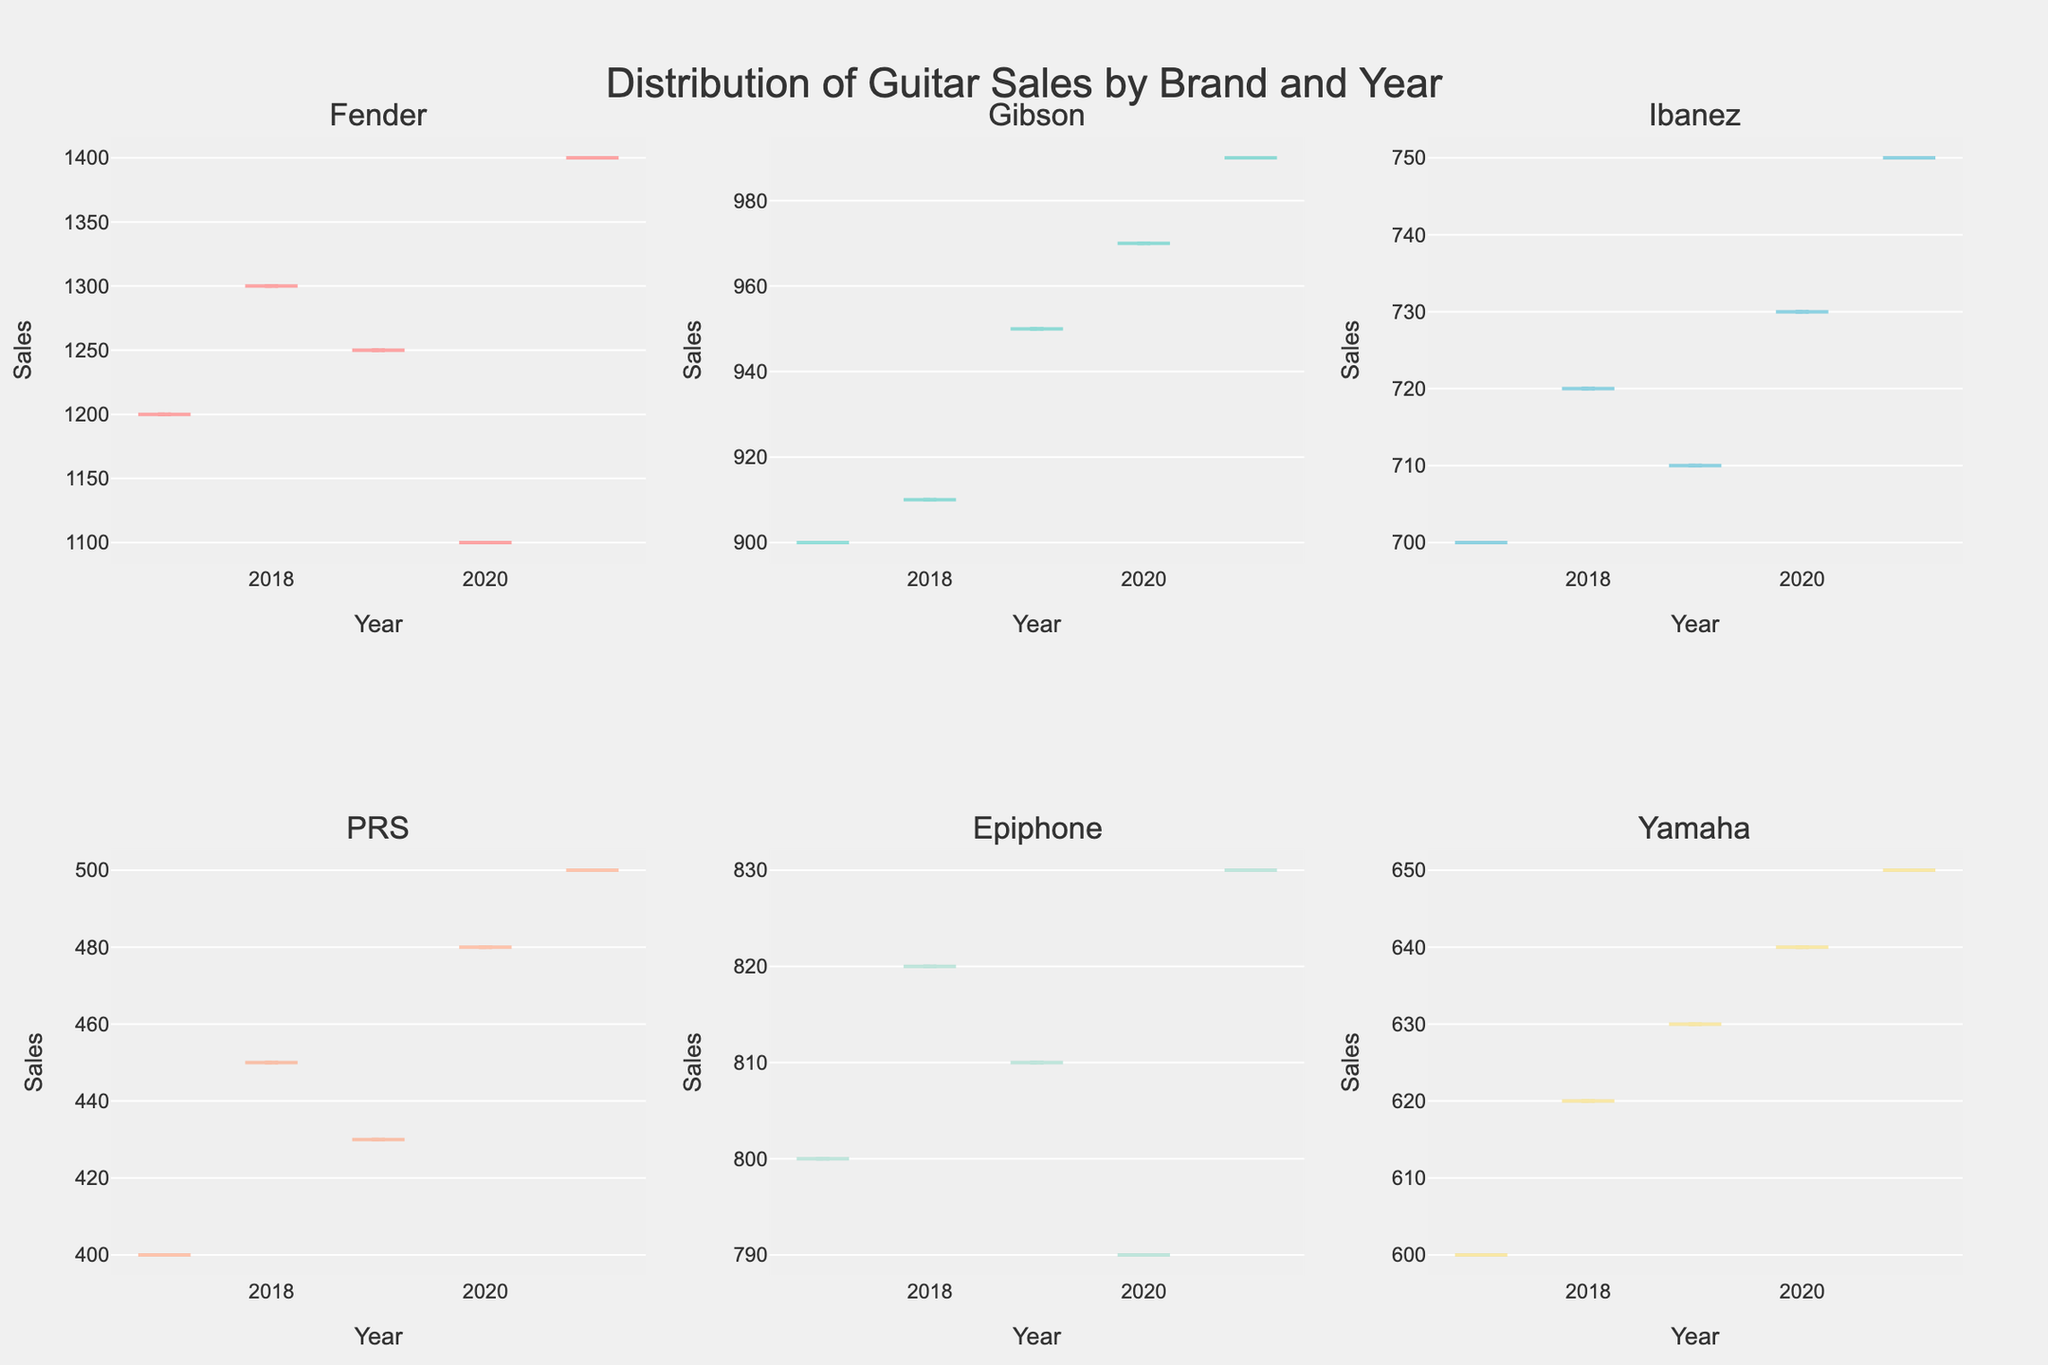What is the title of the figure? The title is centrally located at the top of the figure and is shown in a larger font for emphasis.
Answer: Distribution of Guitar Sales by Brand and Year Which brand had the highest sales in 2021? By looking at the density plot for each brand and specifically checking the data point for 2021, we observe that Fender had the highest sales.
Answer: Fender How many subplot density plots are there in total? The figure is divided into several sections, each representing a different brand. Counting these sections results in six density plots.
Answer: 6 When did PRS have their highest sales according to the density plot? Observing the trend in PRS's subplot, the highest sales occur in 2021.
Answer: 2021 Compare the sales trend of Gibson and Epiphone from 2017 to 2021. Which brand shows a steadier increase over the years? By examining the density plots for both Gibson and Epiphone, we see that Gibson shows a more consistent, steady increase over the years compared to Epiphone.
Answer: Gibson What can you infer about the sales variability of Ibanez guitars over the years? By inspecting the density plot for Ibanez, the sales numbers appear to be more tightly grouped with less spread, indicating lower variability.
Answer: Lower variability Between Fender and Yamaha, which brand showed more significant fluctuation in sales over the years? Comparing the spread and variation in the density plots for Fender and Yamaha, it's evident that Fender has more fluctuation.
Answer: Fender What is the notable trend observed for Yamaha from 2017 to 2021? The density plot for Yamaha indicates a gradual increase in sales each year, showing a positive sales trend.
Answer: Gradual increase What color is used to represent the density plot for PRS guitars? By observing the unique color palette for each subplot, PRS is represented in a distinctive color.
Answer: Light coral shade Which brand has the least sales amount in 2020 and how do you know that? The plot for PRS shows the lowest height and thickness for the year 2020, indicating the least sales amount among all brands.
Answer: PRS 